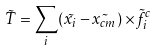Convert formula to latex. <formula><loc_0><loc_0><loc_500><loc_500>\vec { T } = \sum _ { i } ( \vec { x _ { i } } - \vec { x _ { c m } } ) \times \vec { f } _ { i } ^ { c }</formula> 